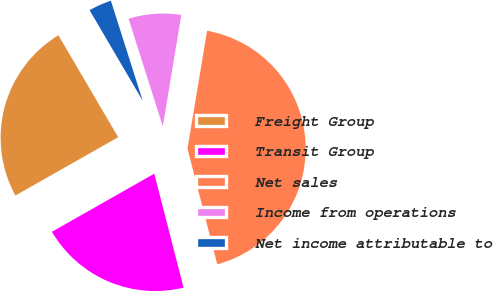Convert chart to OTSL. <chart><loc_0><loc_0><loc_500><loc_500><pie_chart><fcel>Freight Group<fcel>Transit Group<fcel>Net sales<fcel>Income from operations<fcel>Net income attributable to<nl><fcel>24.77%<fcel>20.79%<fcel>43.37%<fcel>7.52%<fcel>3.54%<nl></chart> 